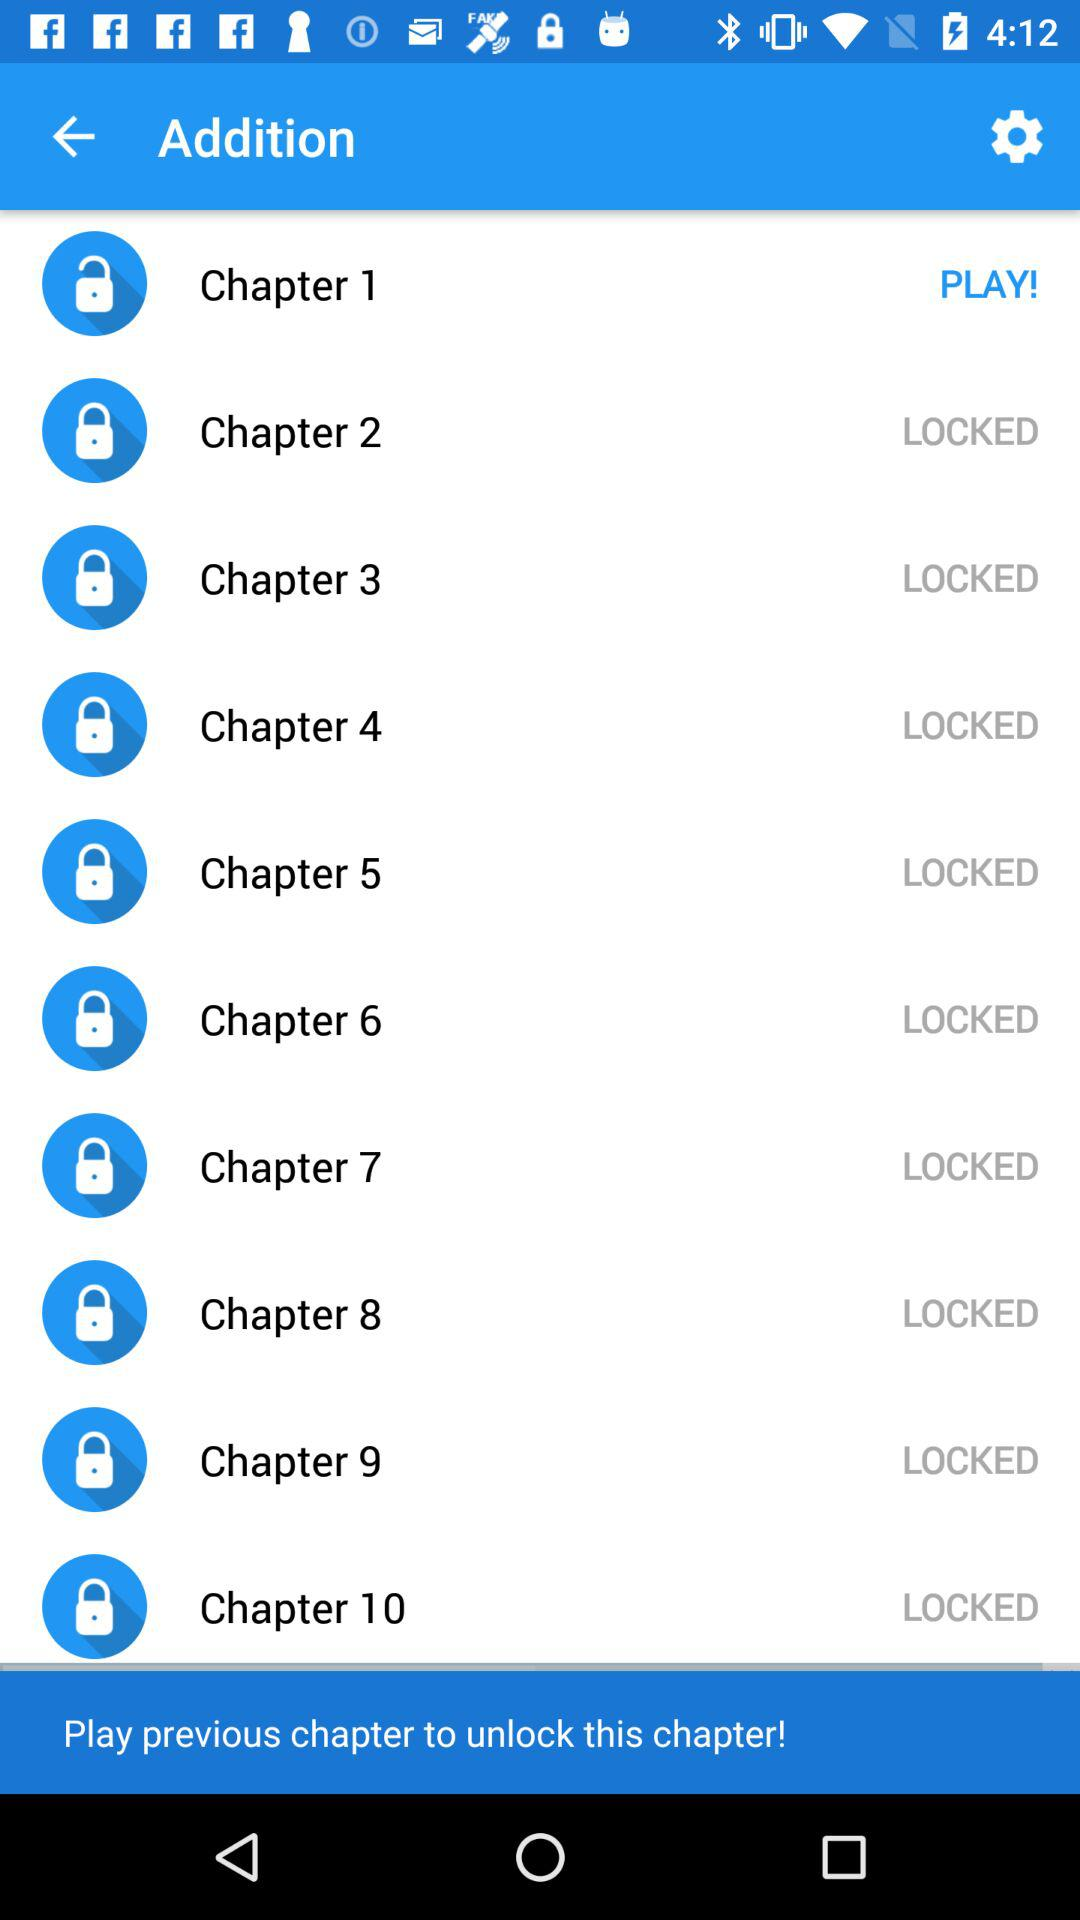How many total chapters are there? There are a total of 10 chapters. 